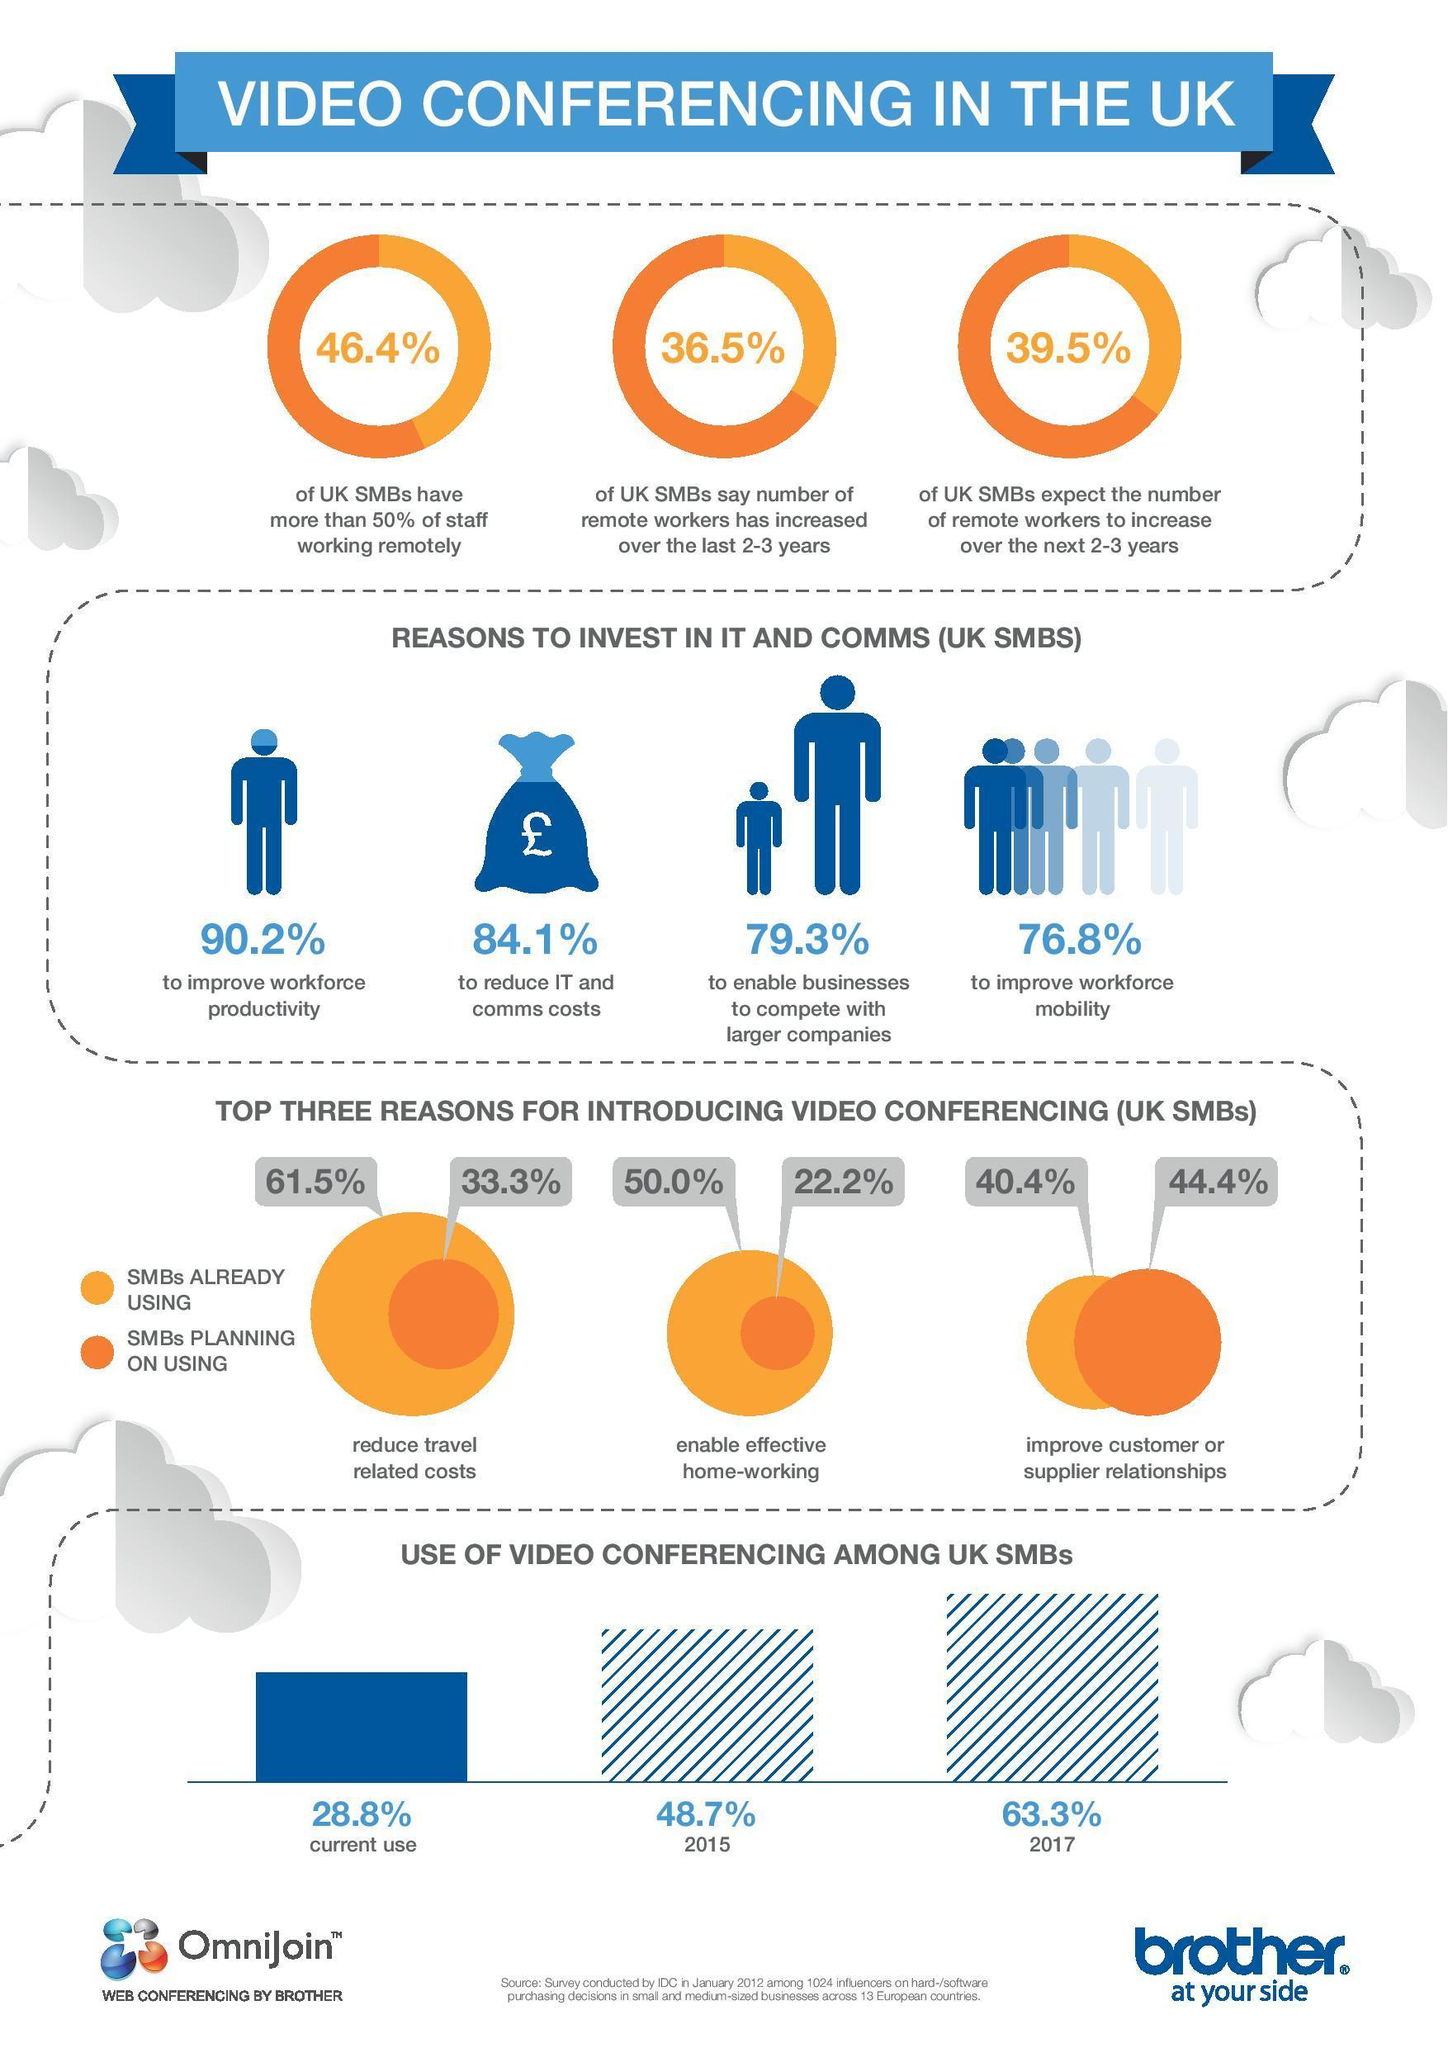What is the estimated percentage use of video conferencing among UK SMBs in 2015?
Answer the question with a short phrase. 48.7% What is the estimated percentage use of video conferencing among UK SMBs in 2017? 63.3% What percentage of UK SMBs are already using video conferencing to improve customer or supplier relationships as per 2012 survey? 40.4% What percentage of UK SMBs are planning to use video conferencing to enable effective home-working according to the 2012 survey? 22.2% What percentage of UK SMBs are planning to use video conferencing to reduce travel related costs as per 2012 survey? 33.3% What percentage of UK SMBs have more than 50% of staff working remotely according to the 2012 survey? 46.4% What percentage of UK SMBs are investing in IT & Comms to improve workforce mobility as per 2012 survey? 76.8% What percentage of UK SMBs are investing in IT & Comms to reduce IT & Comms costs as per 2012 survey? 84.1% What percentage of UK SMBs are already using video conferencing to enable effective home-working as per 2012 survey? 50.0% What percentage of UK SMBs are already using video conferencing to reduce travel related costs according to the 2012 survey? 61.5% 